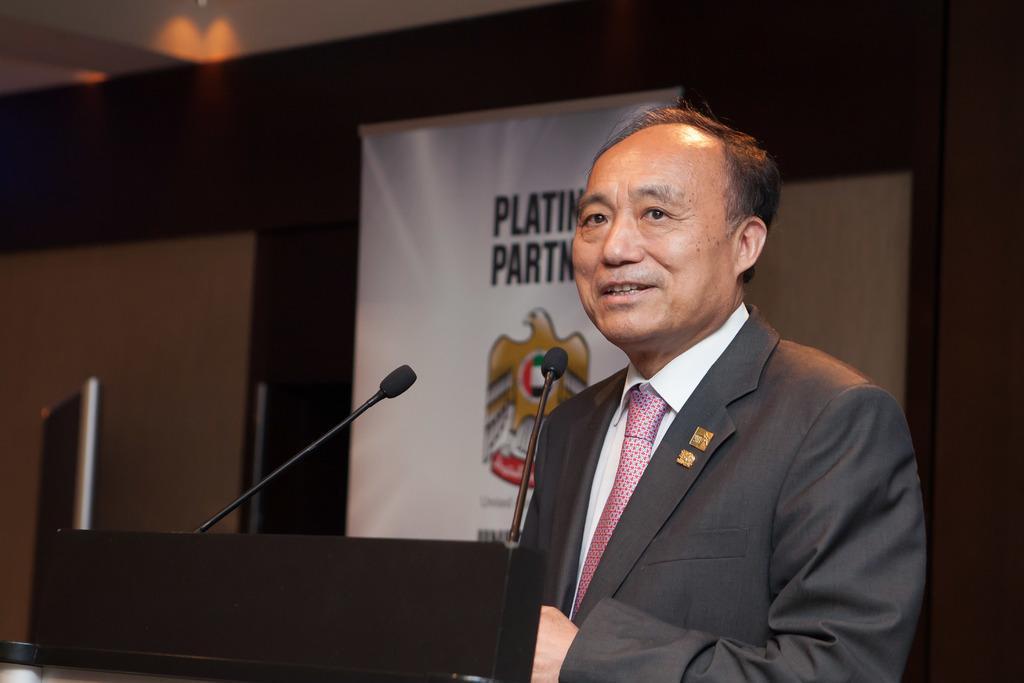In one or two sentences, can you explain what this image depicts? This image consists of a mic. There is a person in the middle. He is wearing a blazer. There is a banner in the middle. 